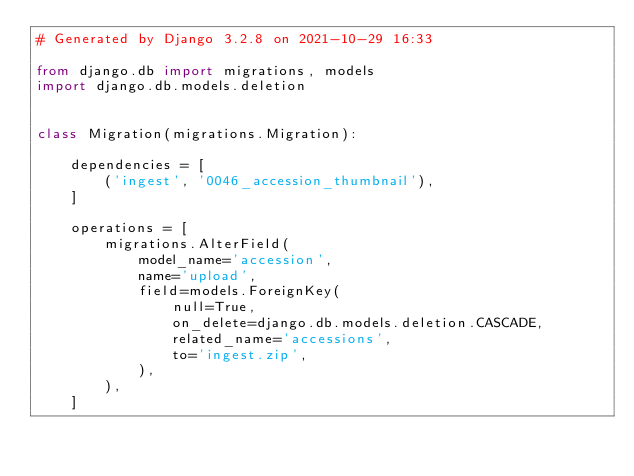Convert code to text. <code><loc_0><loc_0><loc_500><loc_500><_Python_># Generated by Django 3.2.8 on 2021-10-29 16:33

from django.db import migrations, models
import django.db.models.deletion


class Migration(migrations.Migration):

    dependencies = [
        ('ingest', '0046_accession_thumbnail'),
    ]

    operations = [
        migrations.AlterField(
            model_name='accession',
            name='upload',
            field=models.ForeignKey(
                null=True,
                on_delete=django.db.models.deletion.CASCADE,
                related_name='accessions',
                to='ingest.zip',
            ),
        ),
    ]
</code> 